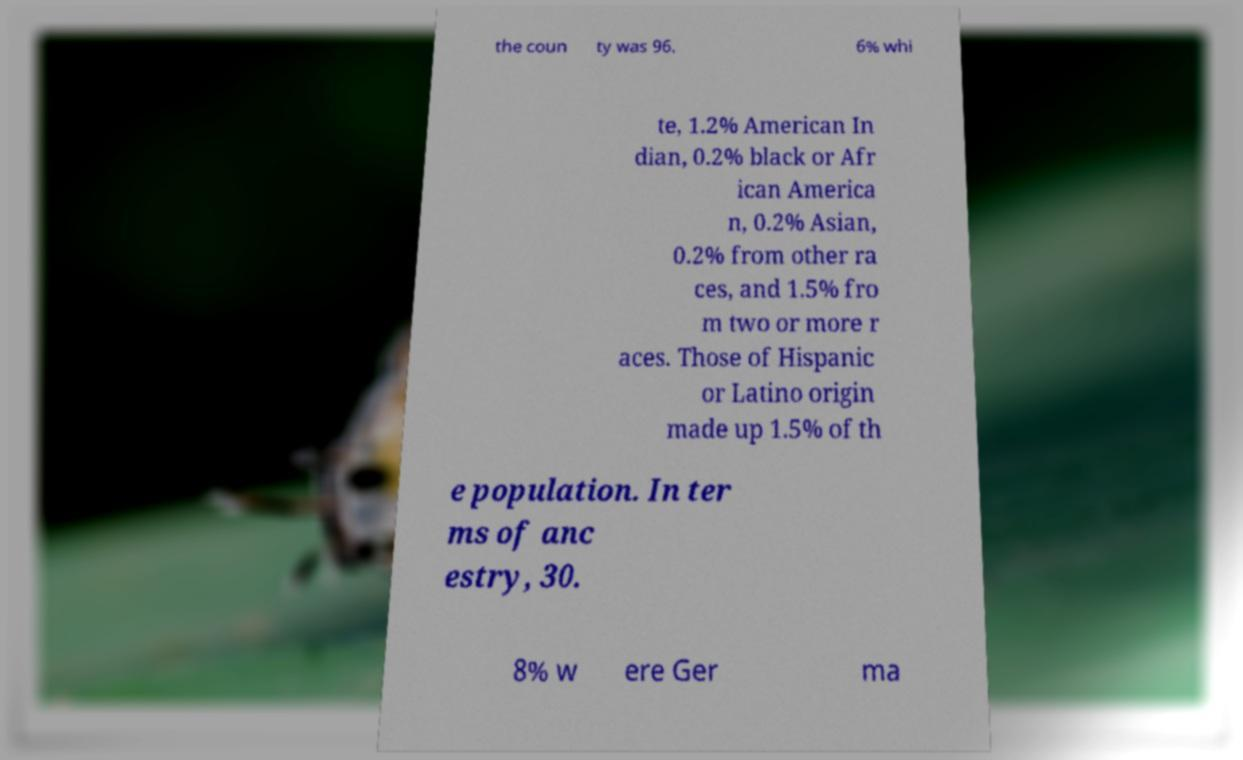For documentation purposes, I need the text within this image transcribed. Could you provide that? the coun ty was 96. 6% whi te, 1.2% American In dian, 0.2% black or Afr ican America n, 0.2% Asian, 0.2% from other ra ces, and 1.5% fro m two or more r aces. Those of Hispanic or Latino origin made up 1.5% of th e population. In ter ms of anc estry, 30. 8% w ere Ger ma 